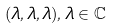Convert formula to latex. <formula><loc_0><loc_0><loc_500><loc_500>( \lambda , \lambda , \lambda ) , \lambda \in \mathbb { C }</formula> 